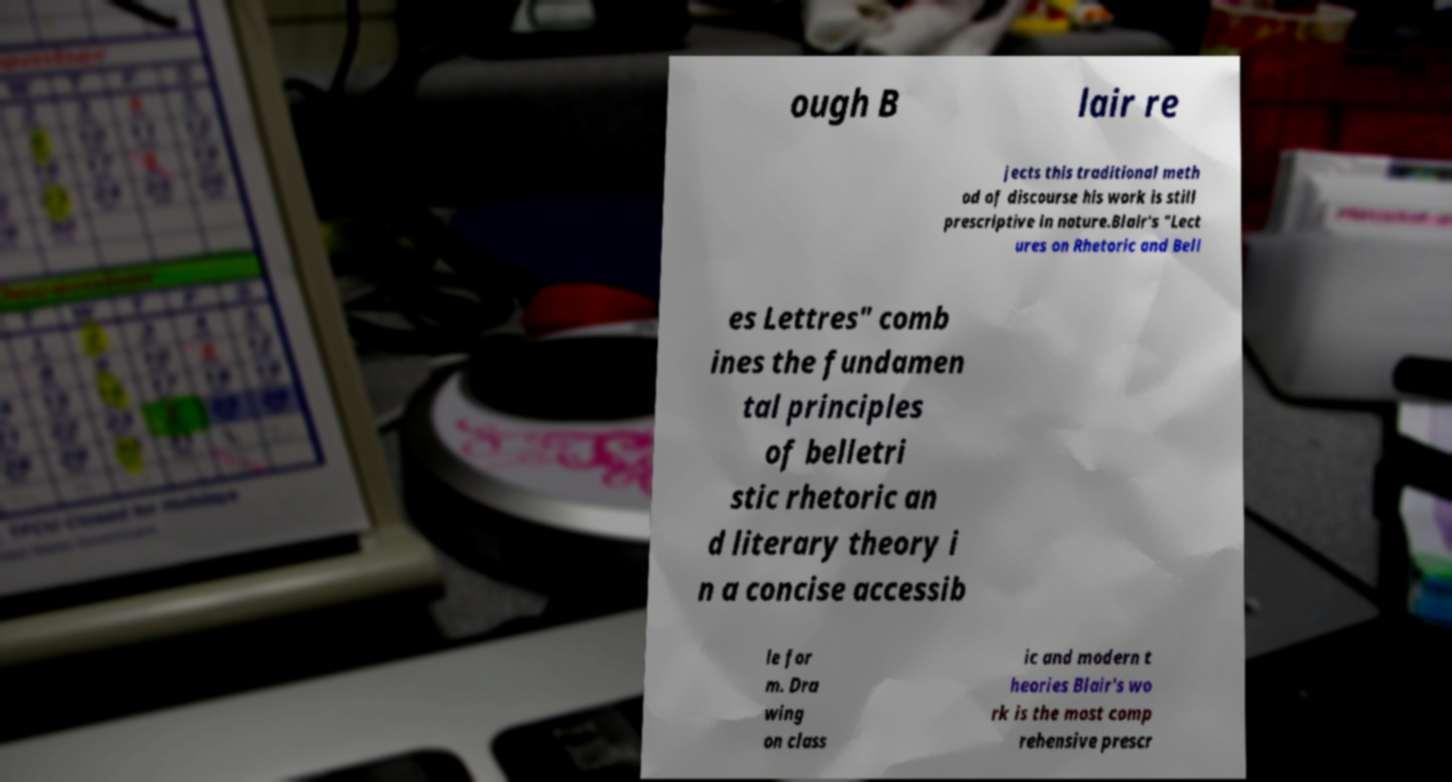What messages or text are displayed in this image? I need them in a readable, typed format. ough B lair re jects this traditional meth od of discourse his work is still prescriptive in nature.Blair's "Lect ures on Rhetoric and Bell es Lettres" comb ines the fundamen tal principles of belletri stic rhetoric an d literary theory i n a concise accessib le for m. Dra wing on class ic and modern t heories Blair's wo rk is the most comp rehensive prescr 